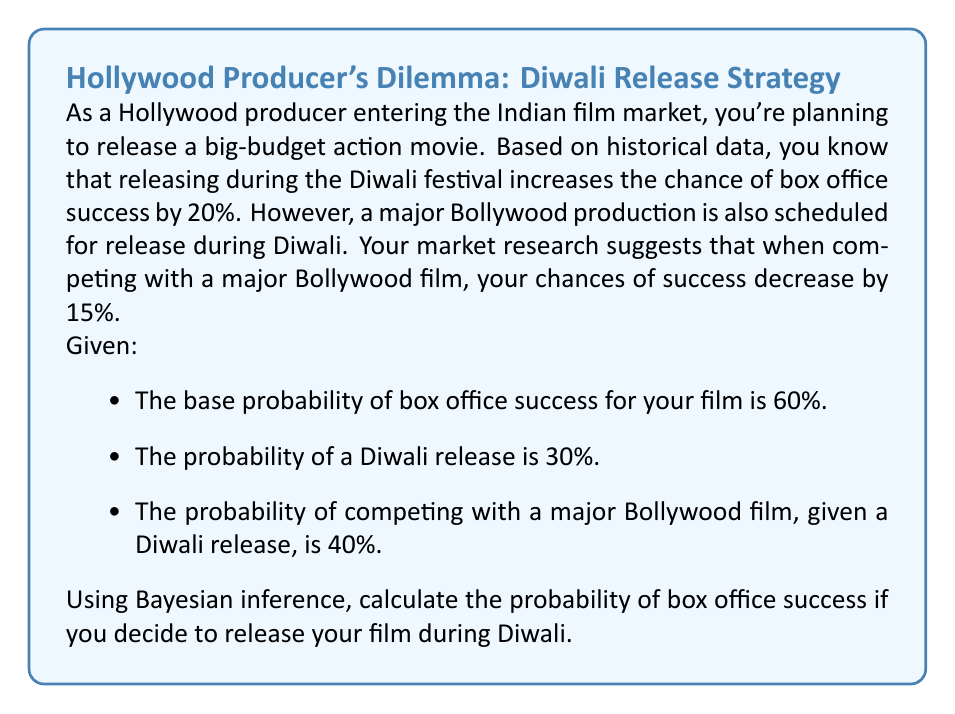Give your solution to this math problem. Let's approach this step-by-step using Bayesian inference:

1) Define our events:
   S: Box office success
   D: Diwali release
   B: Competing with a Bollywood film

2) Given probabilities:
   P(S) = 0.60 (base probability of success)
   P(D) = 0.30 (probability of Diwali release)
   P(B|D) = 0.40 (probability of Bollywood competition given Diwali release)

3) Calculate P(S|D) (probability of success given Diwali release):
   P(S|D) = P(S) + 0.20 = 0.60 + 0.20 = 0.80

4) Calculate P(S|B) (probability of success given Bollywood competition):
   P(S|B) = P(S) - 0.15 = 0.60 - 0.15 = 0.45

5) We need to calculate P(S|D) using the law of total probability:
   P(S|D) = P(S|D,B) * P(B|D) + P(S|D,not B) * P(not B|D)

6) Calculate P(not B|D):
   P(not B|D) = 1 - P(B|D) = 1 - 0.40 = 0.60

7) Calculate P(S|D,B):
   P(S|D,B) = P(S|D) - 0.15 = 0.80 - 0.15 = 0.65

8) Calculate P(S|D,not B):
   P(S|D,not B) = P(S|D) = 0.80

9) Now we can apply the formula from step 5:
   P(S|D) = 0.65 * 0.40 + 0.80 * 0.60
          = 0.26 + 0.48
          = 0.74

Therefore, the probability of box office success if you release your film during Diwali is 0.74 or 74%.
Answer: The probability of box office success if you release your film during Diwali is 0.74 or 74%. 